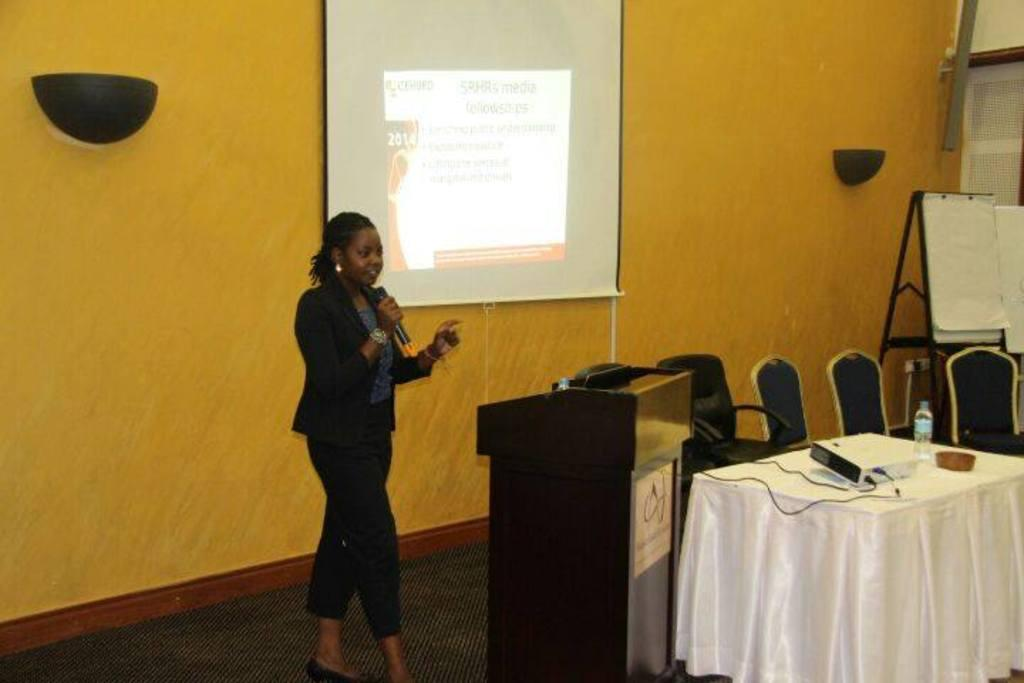What color is the wall in the image? The wall in the image is yellow. What can be seen on the wall? There is a screen on the wall in the image. What piece of furniture is present in the image? There is a table and chairs in the image. What is on the table? There is a board on the table in the image. What is the woman in the image doing? The woman is holding a microphone in the image. What type of grain is being used to make the microphone in the image? There is no grain present in the image, and the microphone is not made of grain. Is there a window visible in the image? No, there is no window visible in the image. 